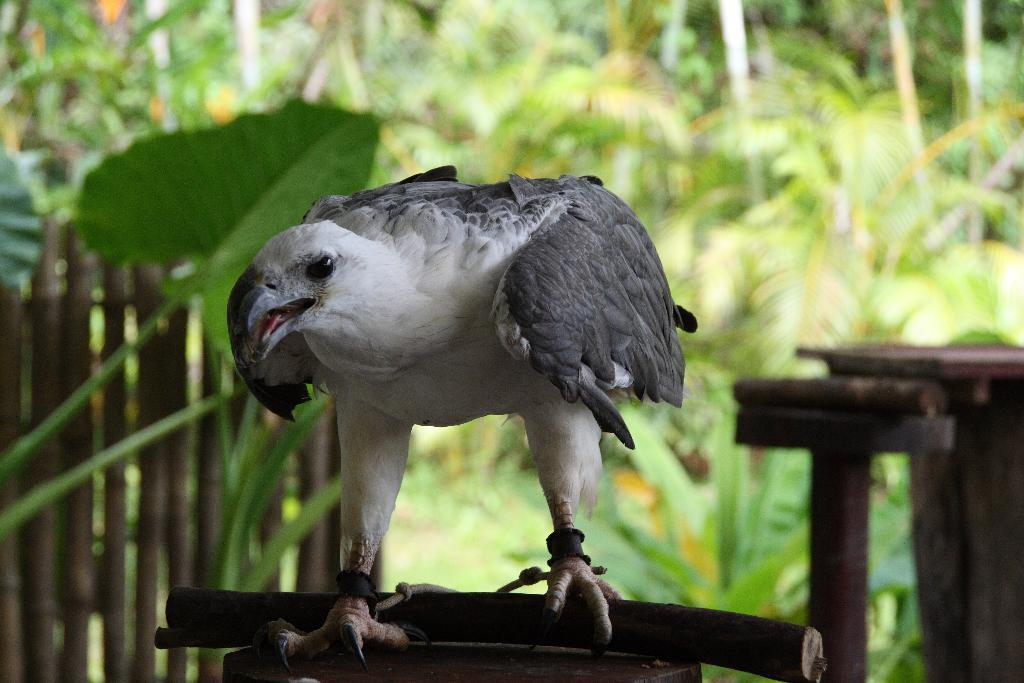What is the main subject in the center of the image? There is a bird in the center of the image. What can be seen in the background of the image? There are many trees in the background of the image. What type of fencing is present in the image? There is a wooden fencing in the image. What type of lamp is hanging from the bird's beak in the image? There is no lamp present in the image, and the bird's beak is not holding any object. 